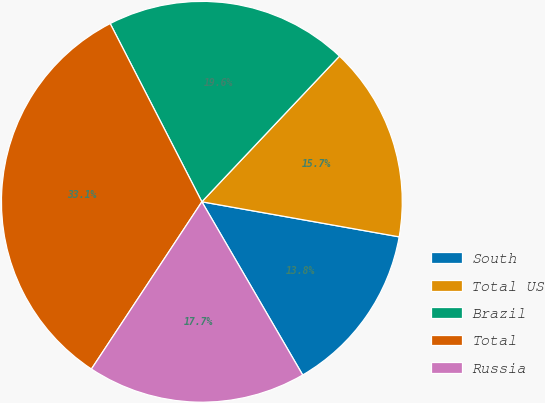Convert chart to OTSL. <chart><loc_0><loc_0><loc_500><loc_500><pie_chart><fcel>South<fcel>Total US<fcel>Brazil<fcel>Total<fcel>Russia<nl><fcel>13.81%<fcel>15.75%<fcel>19.61%<fcel>33.15%<fcel>17.68%<nl></chart> 